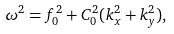<formula> <loc_0><loc_0><loc_500><loc_500>\omega ^ { 2 } = f ^ { 2 } _ { 0 } + C ^ { 2 } _ { 0 } ( k ^ { 2 } _ { x } + k ^ { 2 } _ { y } ) ,</formula> 